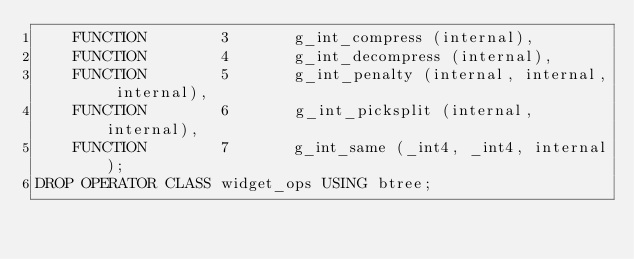Convert code to text. <code><loc_0><loc_0><loc_500><loc_500><_SQL_>    FUNCTION        3       g_int_compress (internal),
    FUNCTION        4       g_int_decompress (internal),
    FUNCTION        5       g_int_penalty (internal, internal, internal),
    FUNCTION        6       g_int_picksplit (internal, internal),
    FUNCTION        7       g_int_same (_int4, _int4, internal);
DROP OPERATOR CLASS widget_ops USING btree;</code> 